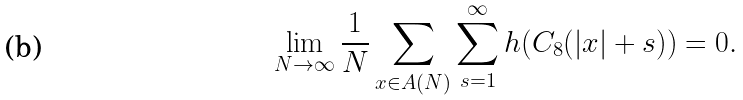<formula> <loc_0><loc_0><loc_500><loc_500>\lim _ { N \to \infty } \frac { 1 } { N } \sum _ { x \in A ( N ) } \sum _ { s = 1 } ^ { \infty } h ( C _ { 8 } ( | x | + s ) ) = 0 .</formula> 